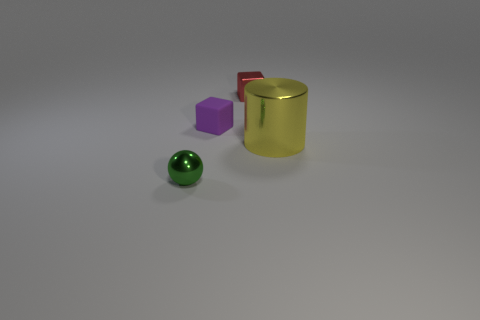Add 3 green metallic spheres. How many objects exist? 7 Subtract all cylinders. How many objects are left? 3 Add 3 yellow metal objects. How many yellow metal objects exist? 4 Subtract 0 gray cylinders. How many objects are left? 4 Subtract 1 spheres. How many spheres are left? 0 Subtract all red blocks. Subtract all gray cylinders. How many blocks are left? 1 Subtract all green spheres. How many purple blocks are left? 1 Subtract all purple things. Subtract all big yellow cylinders. How many objects are left? 2 Add 4 small matte objects. How many small matte objects are left? 5 